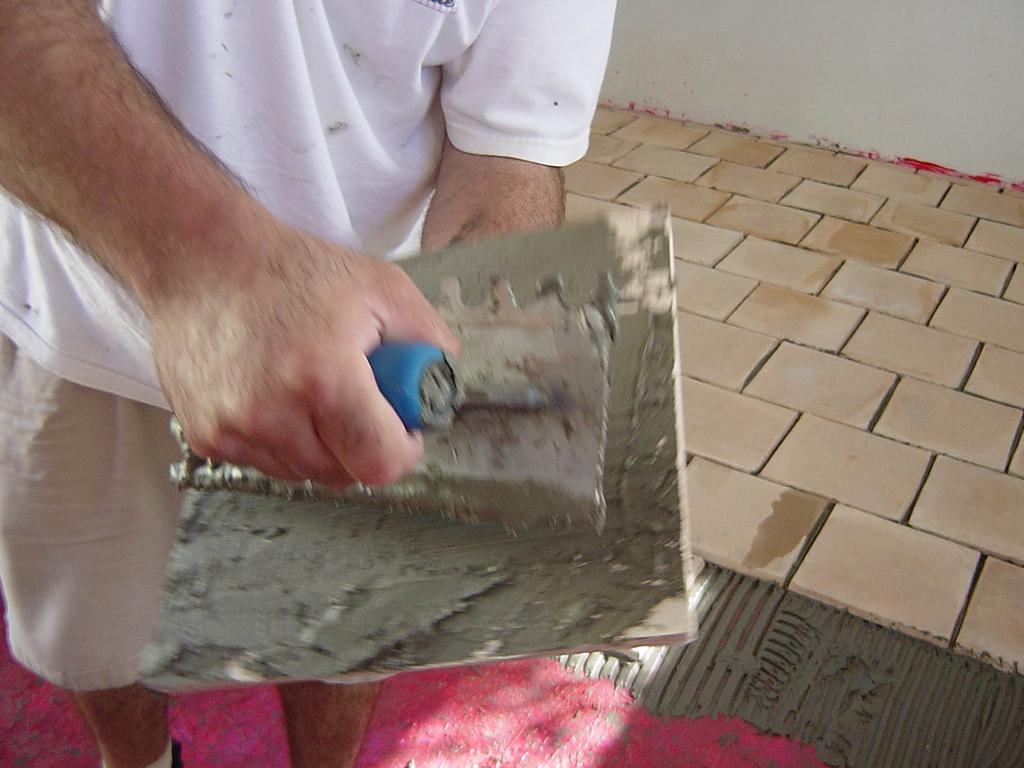Can you describe this image briefly? In this image, we can see a person who´is face is not visible holding a tool and tile with hands. This person is standing and wearing clothes. There is a wall in the top right of the image. 